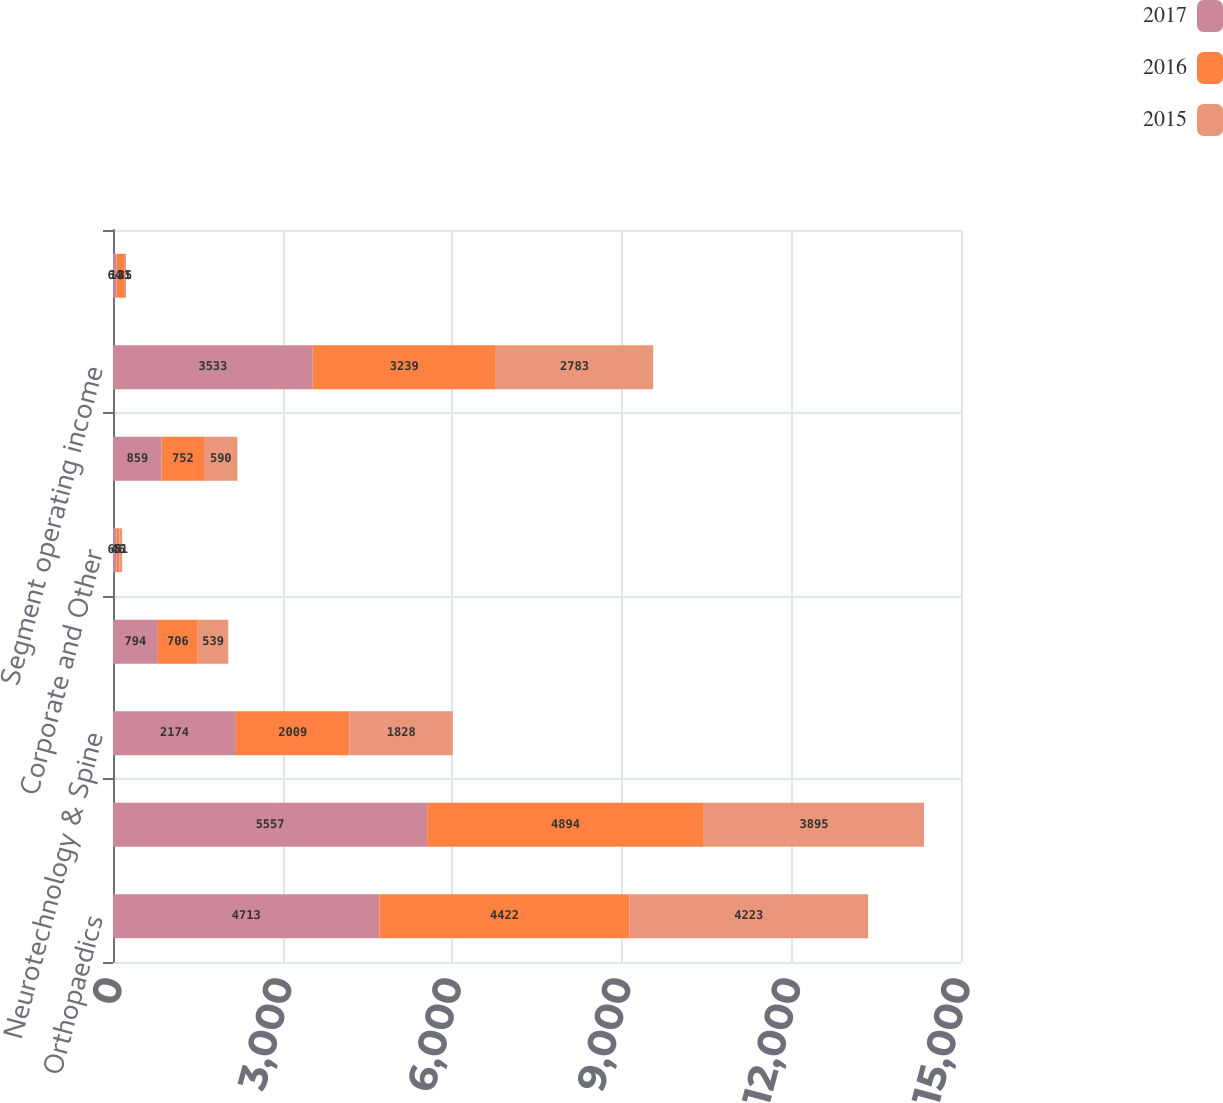Convert chart. <chart><loc_0><loc_0><loc_500><loc_500><stacked_bar_chart><ecel><fcel>Orthopaedics<fcel>MedSurg<fcel>Neurotechnology & Spine<fcel>Segment depreciation and<fcel>Corporate and Other<fcel>Total depreciation and<fcel>Segment operating income<fcel>Acquisition &<nl><fcel>2017<fcel>4713<fcel>5557<fcel>2174<fcel>794<fcel>65<fcel>859<fcel>3533<fcel>64<nl><fcel>2016<fcel>4422<fcel>4894<fcel>2009<fcel>706<fcel>46<fcel>752<fcel>3239<fcel>131<nl><fcel>2015<fcel>4223<fcel>3895<fcel>1828<fcel>539<fcel>51<fcel>590<fcel>2783<fcel>35<nl></chart> 